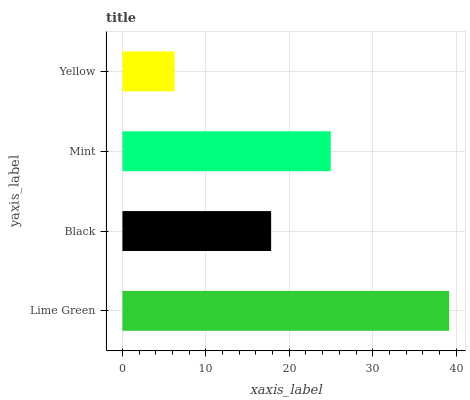Is Yellow the minimum?
Answer yes or no. Yes. Is Lime Green the maximum?
Answer yes or no. Yes. Is Black the minimum?
Answer yes or no. No. Is Black the maximum?
Answer yes or no. No. Is Lime Green greater than Black?
Answer yes or no. Yes. Is Black less than Lime Green?
Answer yes or no. Yes. Is Black greater than Lime Green?
Answer yes or no. No. Is Lime Green less than Black?
Answer yes or no. No. Is Mint the high median?
Answer yes or no. Yes. Is Black the low median?
Answer yes or no. Yes. Is Yellow the high median?
Answer yes or no. No. Is Lime Green the low median?
Answer yes or no. No. 